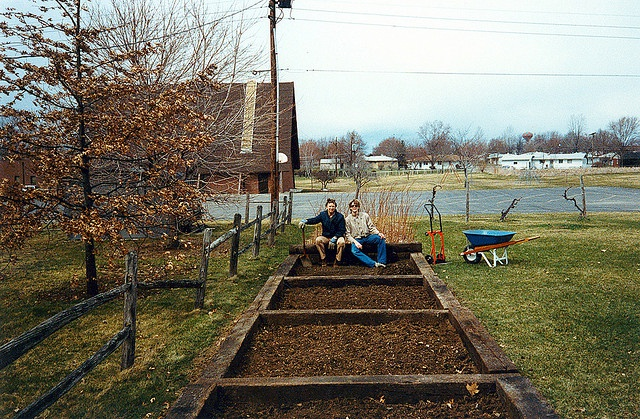Describe the objects in this image and their specific colors. I can see people in white, black, lightgray, blue, and navy tones and people in white, black, navy, maroon, and gray tones in this image. 